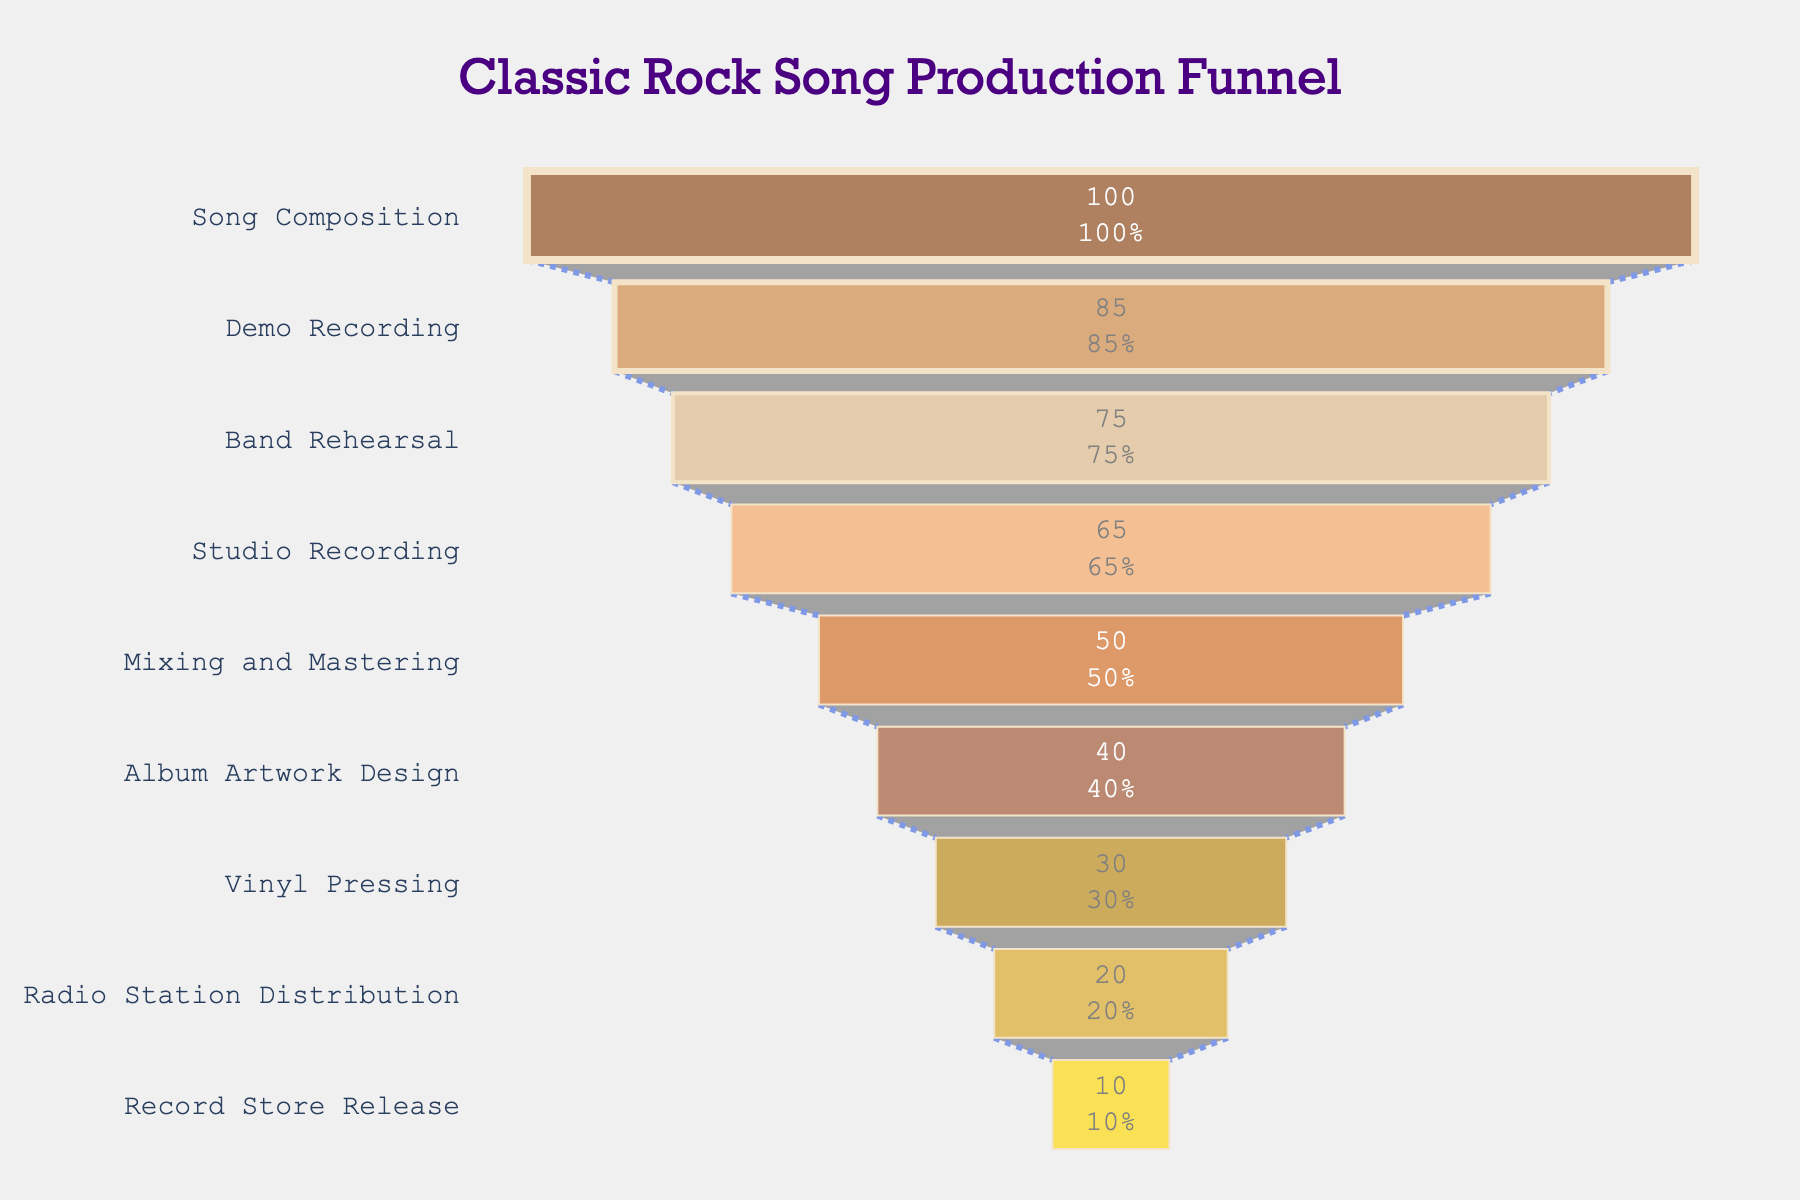Which stage sees the biggest drop in percentage compared to the previous stage? By comparing each stage's percentage to the previous one, the largest drop occurs between "Mixing and Mastering" (50%) and "Studio Recording" (65%), which is a drop of 15%.
Answer: Mixing and Mastering What percentage of the process is left after the "Band Rehearsal" stage? The stages after "Band Rehearsal" are Studio Recording (65%), Mixing and Mastering (50%), Album Artwork Design (40%), Vinyl Pressing (30%), Radio Station Distribution (20%), and Record Store Release (10%). So the remaining percentage at "Band Rehearsal" is from 75% - 10%.
Answer: 25% Which stage directly follows "Song Composition" in the production funnel? From the funnel chart, the stage that follows "Song Composition" (100%) is "Demo Recording" (85%).
Answer: Demo Recording How many stages in the funnel have a percentage greater than 50%? The stages with more than 50% are "Song Composition" (100%), "Demo Recording" (85%), "Band Rehearsal" (75%), and "Studio Recording" (65%).
Answer: 4 Is the percentage at "Vinyl Pressing" higher or lower than at "Album Artwork Design"? The percentage at "Vinyl Pressing" (30%) is lower than at "Album Artwork Design" (40%).
Answer: Lower What stage represents the midpoint in the classic rock song production process? To find the midpoint stage, we look for the stage around the middle of the production funnel. "Studio Recording" (65%) is the midpoint given the funnel's stages.
Answer: Studio Recording What is the cumulative percentage reduction from "Mixing and Mastering" to "Record Store Release"? Subtract the percentage at "Record Store Release" (10%) from "Mixing and Mastering" (50%), which gives 50% - 10% = 40%. The cumulative reduction is 40%.
Answer: 40% How does the percentage change from "Demo Recording" to "Band Rehearsal"? The percentage decreases from "Demo Recording" (85%) to "Band Rehearsal" (75%). The change is 85% - 75% = 10%.
Answer: 10% What is the total percentage reduction from "Song Composition" to "Record Store Release"? Starting at 100% (Song Composition) and ending at 10% (Record Store Release), the total reduction is 100% - 10% = 90%.
Answer: 90% What is the final stage in the classic rock song production funnel? The last stage listed in the funnel is "Record Store Release," which has a percentage of 10%.
Answer: Record Store Release 